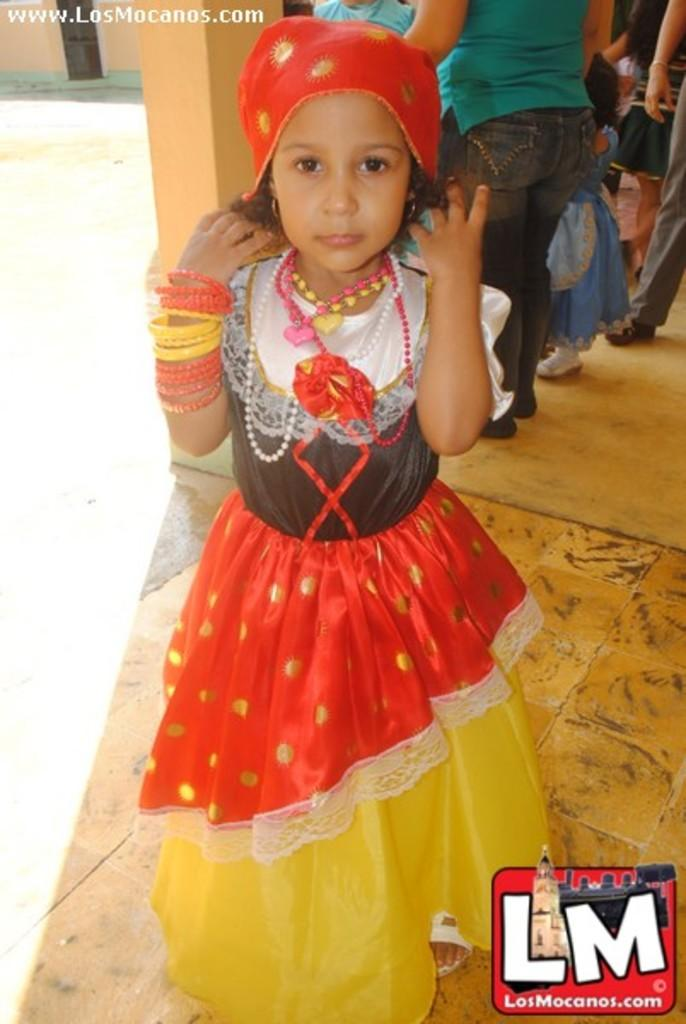Who is the main subject in the image? There is a girl in the image. What is the girl wearing on her head? The girl is wearing a red color headgear. What is the girl's posture in the image? The girl is standing. What is the surface beneath the girl's feet? There is a floor in the image. What can be seen in the background of the image? There are many people and a pillar in the background of the image. What type of money can be seen in the girl's hand in the image? There is no money visible in the girl's hand or anywhere in the image. What sign is the girl holding in the image? The girl is not holding any sign in the image. 